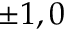<formula> <loc_0><loc_0><loc_500><loc_500>\pm 1 , 0</formula> 